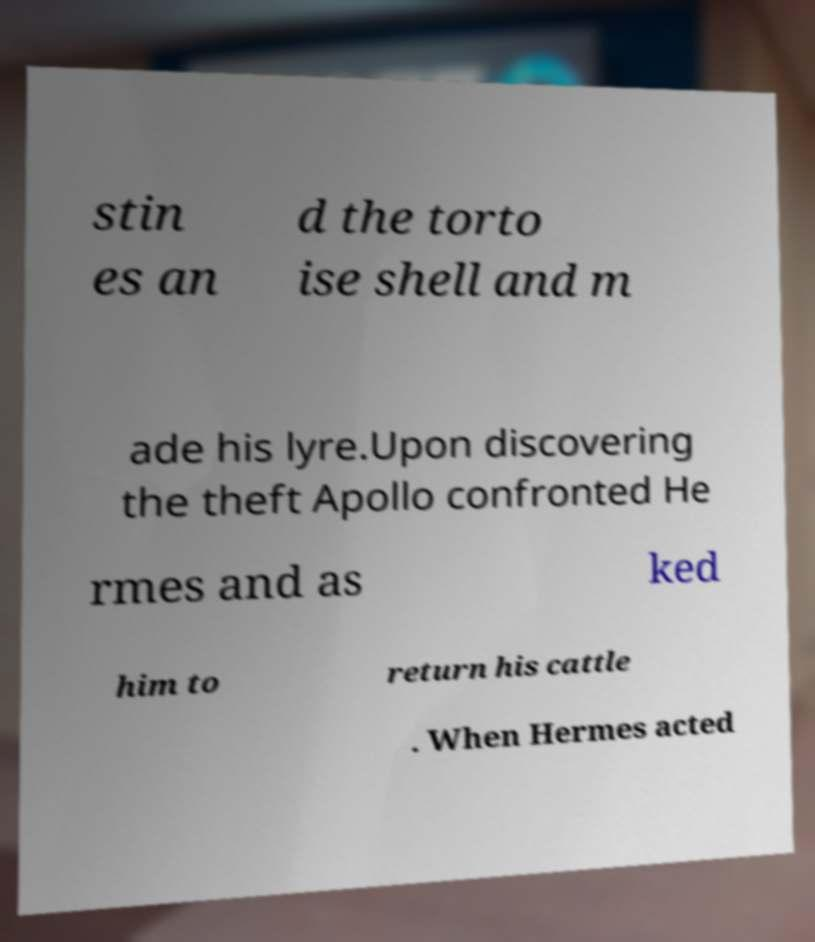Please read and relay the text visible in this image. What does it say? stin es an d the torto ise shell and m ade his lyre.Upon discovering the theft Apollo confronted He rmes and as ked him to return his cattle . When Hermes acted 